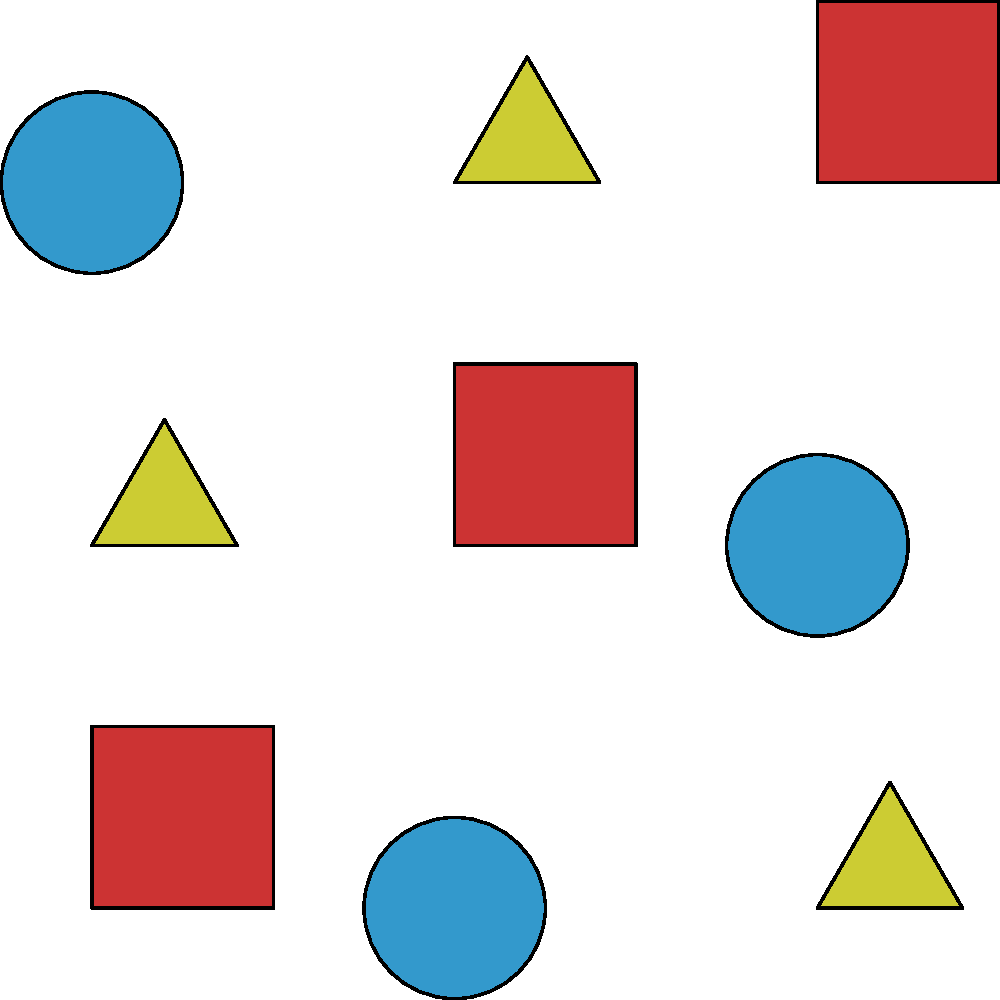In the pattern above, which shape appears in the top right corner? To answer this question, we need to follow these steps:

1. Understand the orientation: In this context, "top right" refers to the upper right corner of the image.

2. Identify the shapes: The pattern consists of three different shapes:
   - Squares (red)
   - Circles (blue)
   - Triangles (yellow)

3. Locate the top right position: In a 3x3 grid, the top right position would be in the third row and third column.

4. Observe the shape in that position: The shape in the top right corner (3rd row, 3rd column) is a square.

5. Confirm the shape: The square in the top right corner is colored red, consistent with the other squares in the pattern.

Therefore, the shape that appears in the top right corner of the pattern is a square.
Answer: Square 